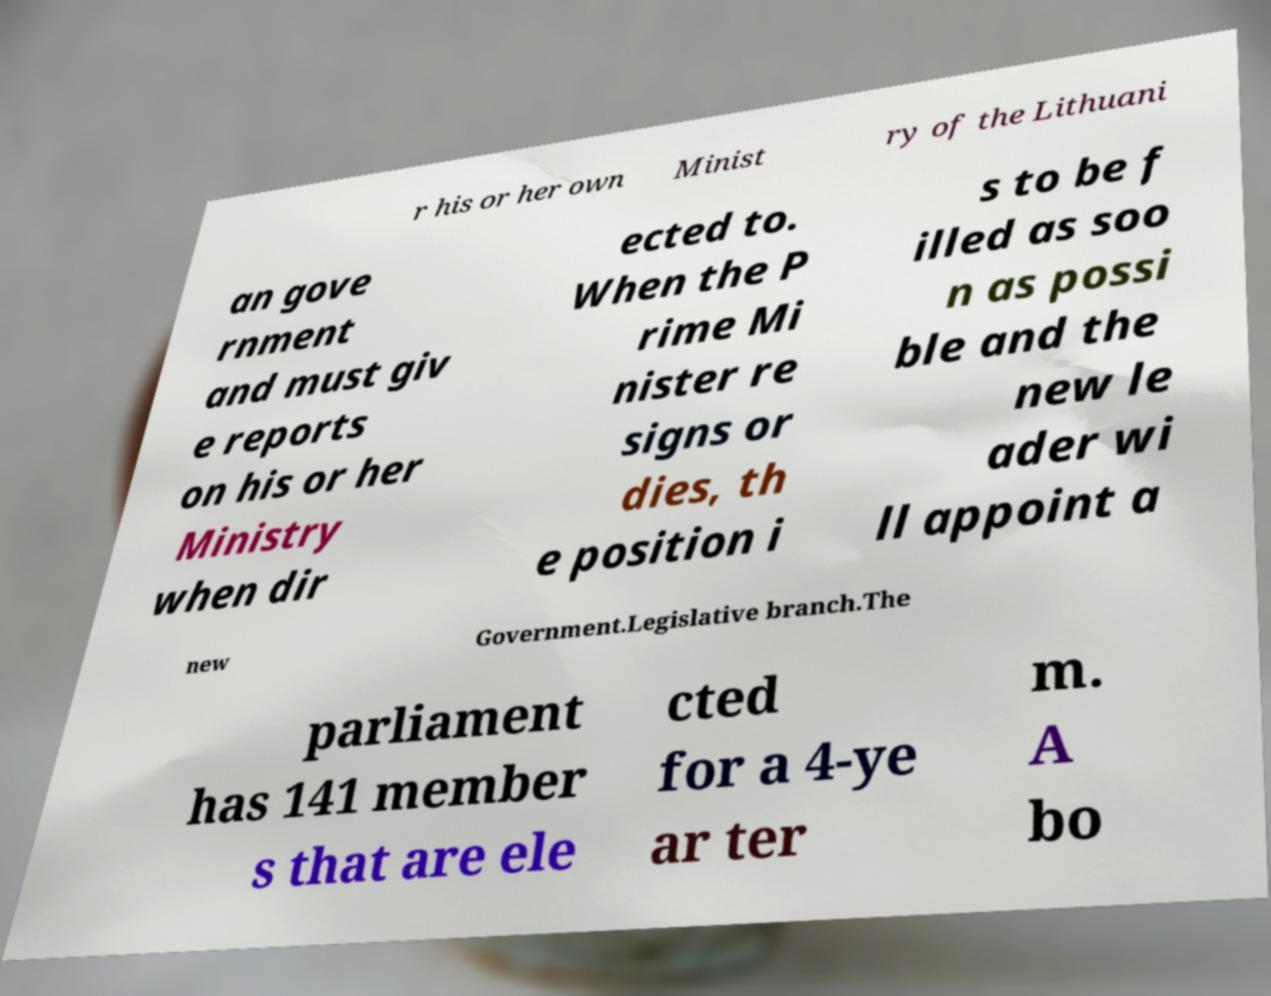Can you accurately transcribe the text from the provided image for me? r his or her own Minist ry of the Lithuani an gove rnment and must giv e reports on his or her Ministry when dir ected to. When the P rime Mi nister re signs or dies, th e position i s to be f illed as soo n as possi ble and the new le ader wi ll appoint a new Government.Legislative branch.The parliament has 141 member s that are ele cted for a 4-ye ar ter m. A bo 